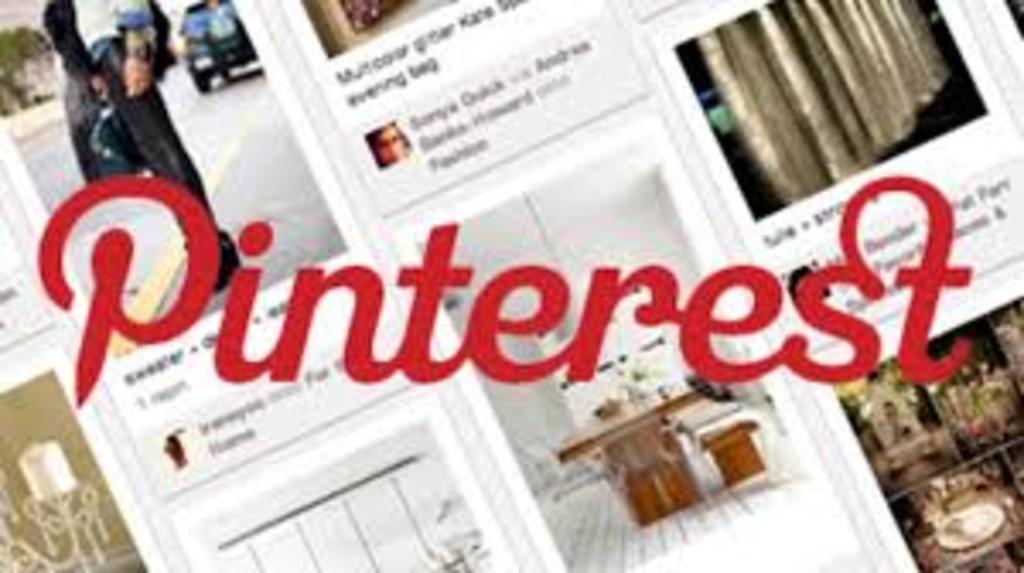Could you give a brief overview of what you see in this image? This is an edited image. In this image we can see some pictures and text on it. 